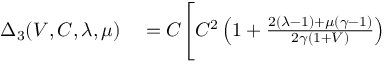Convert formula to latex. <formula><loc_0><loc_0><loc_500><loc_500>\begin{array} { r l } { \Delta _ { 3 } ( V , C , \lambda , \mu ) } & = C \Big [ C ^ { 2 } \left ( 1 + \frac { 2 ( \lambda - 1 ) + \mu ( \gamma - 1 ) } { 2 \gamma ( 1 + V ) } \right ) } \end{array}</formula> 